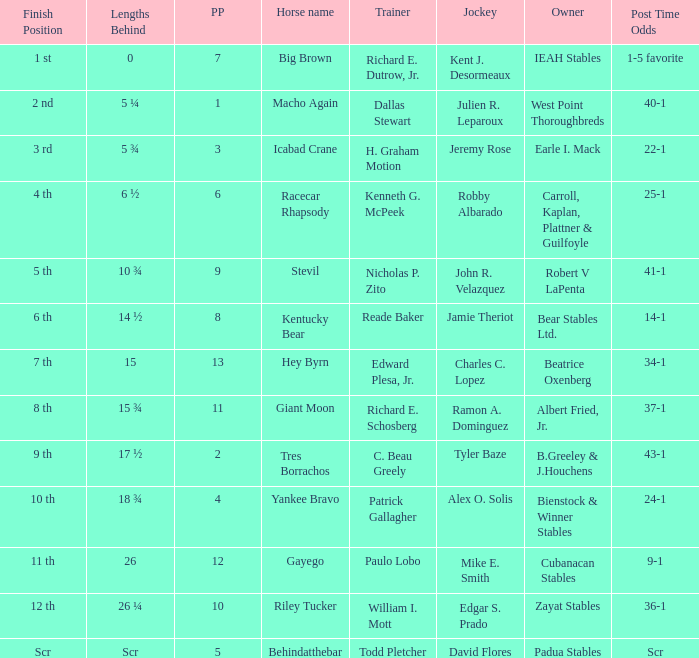What's the lengths behind of Jockey Ramon A. Dominguez? 15 ¾. 